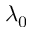Convert formula to latex. <formula><loc_0><loc_0><loc_500><loc_500>\lambda _ { 0 }</formula> 